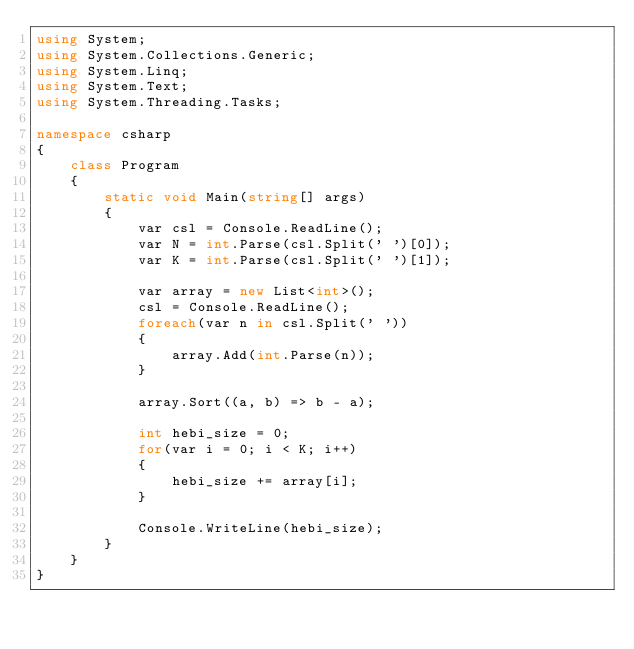<code> <loc_0><loc_0><loc_500><loc_500><_C#_>using System;
using System.Collections.Generic;
using System.Linq;
using System.Text;
using System.Threading.Tasks;

namespace csharp
{
    class Program
    {
        static void Main(string[] args)
        {
            var csl = Console.ReadLine();
            var N = int.Parse(csl.Split(' ')[0]);
            var K = int.Parse(csl.Split(' ')[1]);

            var array = new List<int>();
            csl = Console.ReadLine();
            foreach(var n in csl.Split(' '))
            {
                array.Add(int.Parse(n));    
            }

            array.Sort((a, b) => b - a);

            int hebi_size = 0;
            for(var i = 0; i < K; i++)
            {
                hebi_size += array[i];
            }

            Console.WriteLine(hebi_size);
        }
    }
}</code> 